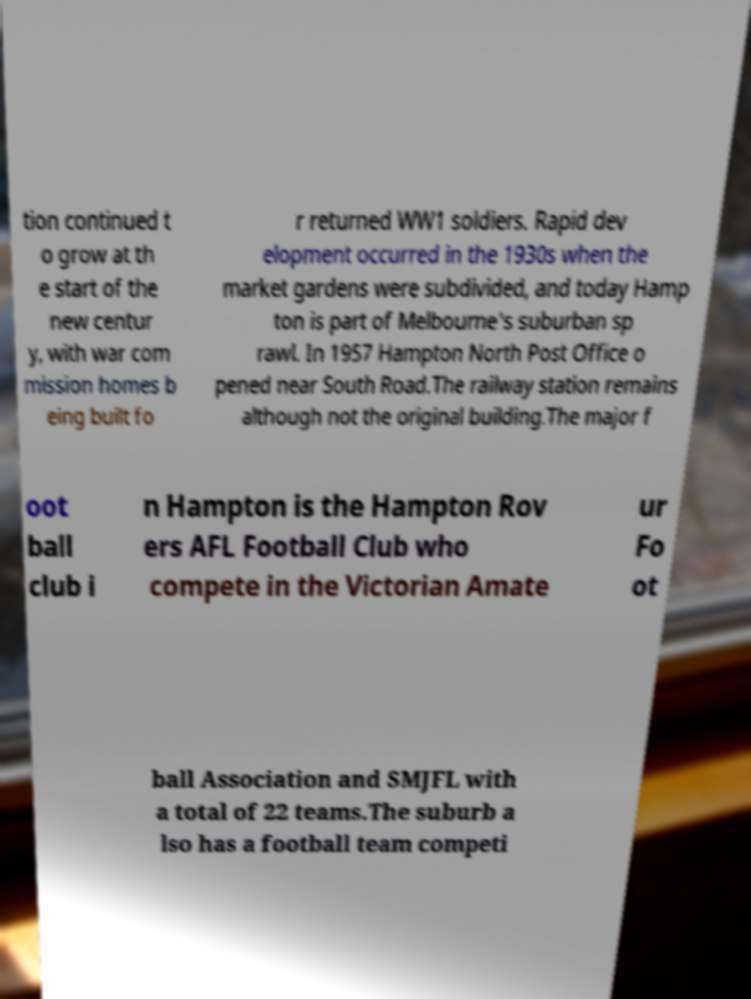There's text embedded in this image that I need extracted. Can you transcribe it verbatim? tion continued t o grow at th e start of the new centur y, with war com mission homes b eing built fo r returned WW1 soldiers. Rapid dev elopment occurred in the 1930s when the market gardens were subdivided, and today Hamp ton is part of Melbourne's suburban sp rawl. In 1957 Hampton North Post Office o pened near South Road.The railway station remains although not the original building.The major f oot ball club i n Hampton is the Hampton Rov ers AFL Football Club who compete in the Victorian Amate ur Fo ot ball Association and SMJFL with a total of 22 teams.The suburb a lso has a football team competi 